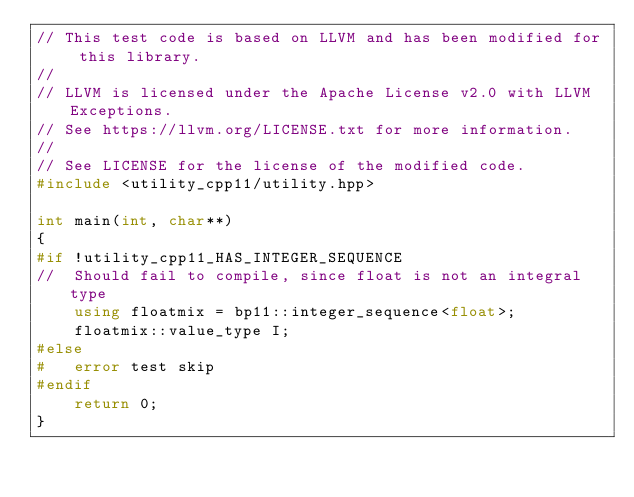Convert code to text. <code><loc_0><loc_0><loc_500><loc_500><_C++_>// This test code is based on LLVM and has been modified for this library.
//
// LLVM is licensed under the Apache License v2.0 with LLVM Exceptions.
// See https://llvm.org/LICENSE.txt for more information.
//
// See LICENSE for the license of the modified code.
#include <utility_cpp11/utility.hpp>

int main(int, char**)
{
#if !utility_cpp11_HAS_INTEGER_SEQUENCE
//  Should fail to compile, since float is not an integral type
    using floatmix = bp11::integer_sequence<float>;
    floatmix::value_type I;
#else
#   error test skip
#endif
    return 0;
}
</code> 